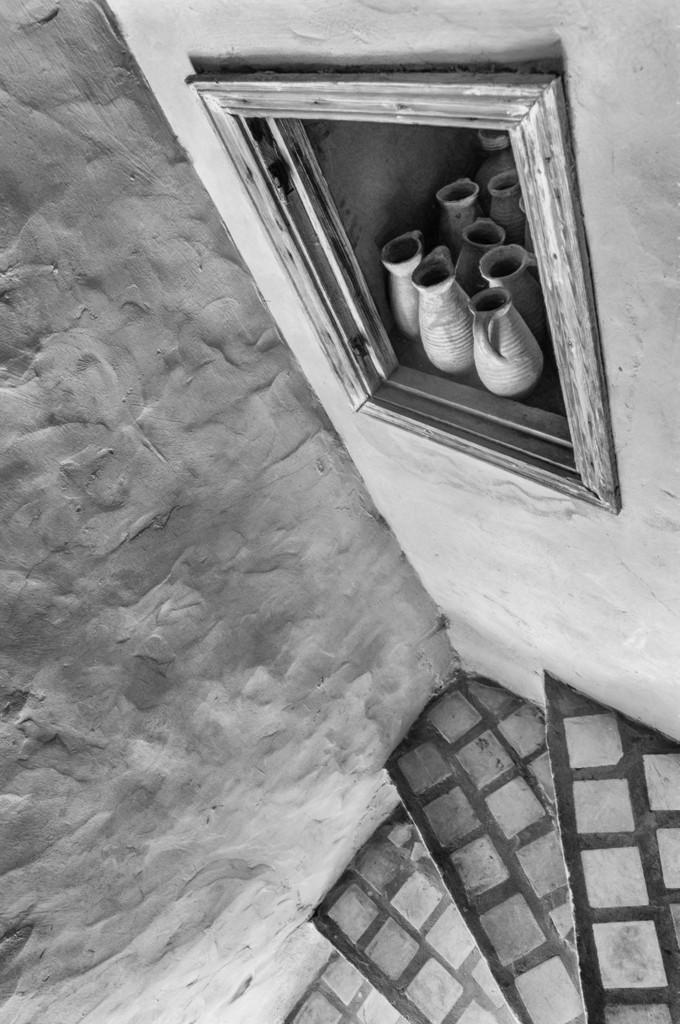What is the color scheme of the image? The image is black and white. What can be seen at the bottom of the image? There is a staircase at the bottom of the image. What is one of the architectural features in the image? There is a wall in the image. What is on the wall in the image? There is a shelf in the image. What is on the shelf? There are flasks on the shelf. What type of advertisement can be seen on the wall in the image? There is no advertisement present on the wall in the image. What type of punishment is being administered in the image? There is no punishment being administered in the image; it features a staircase, a wall, a shelf, and flasks. 